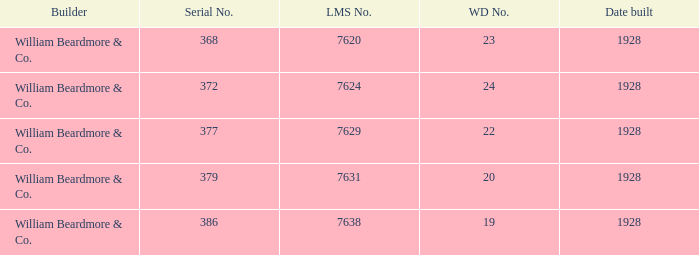Name the lms number for serial number being 372 7624.0. 